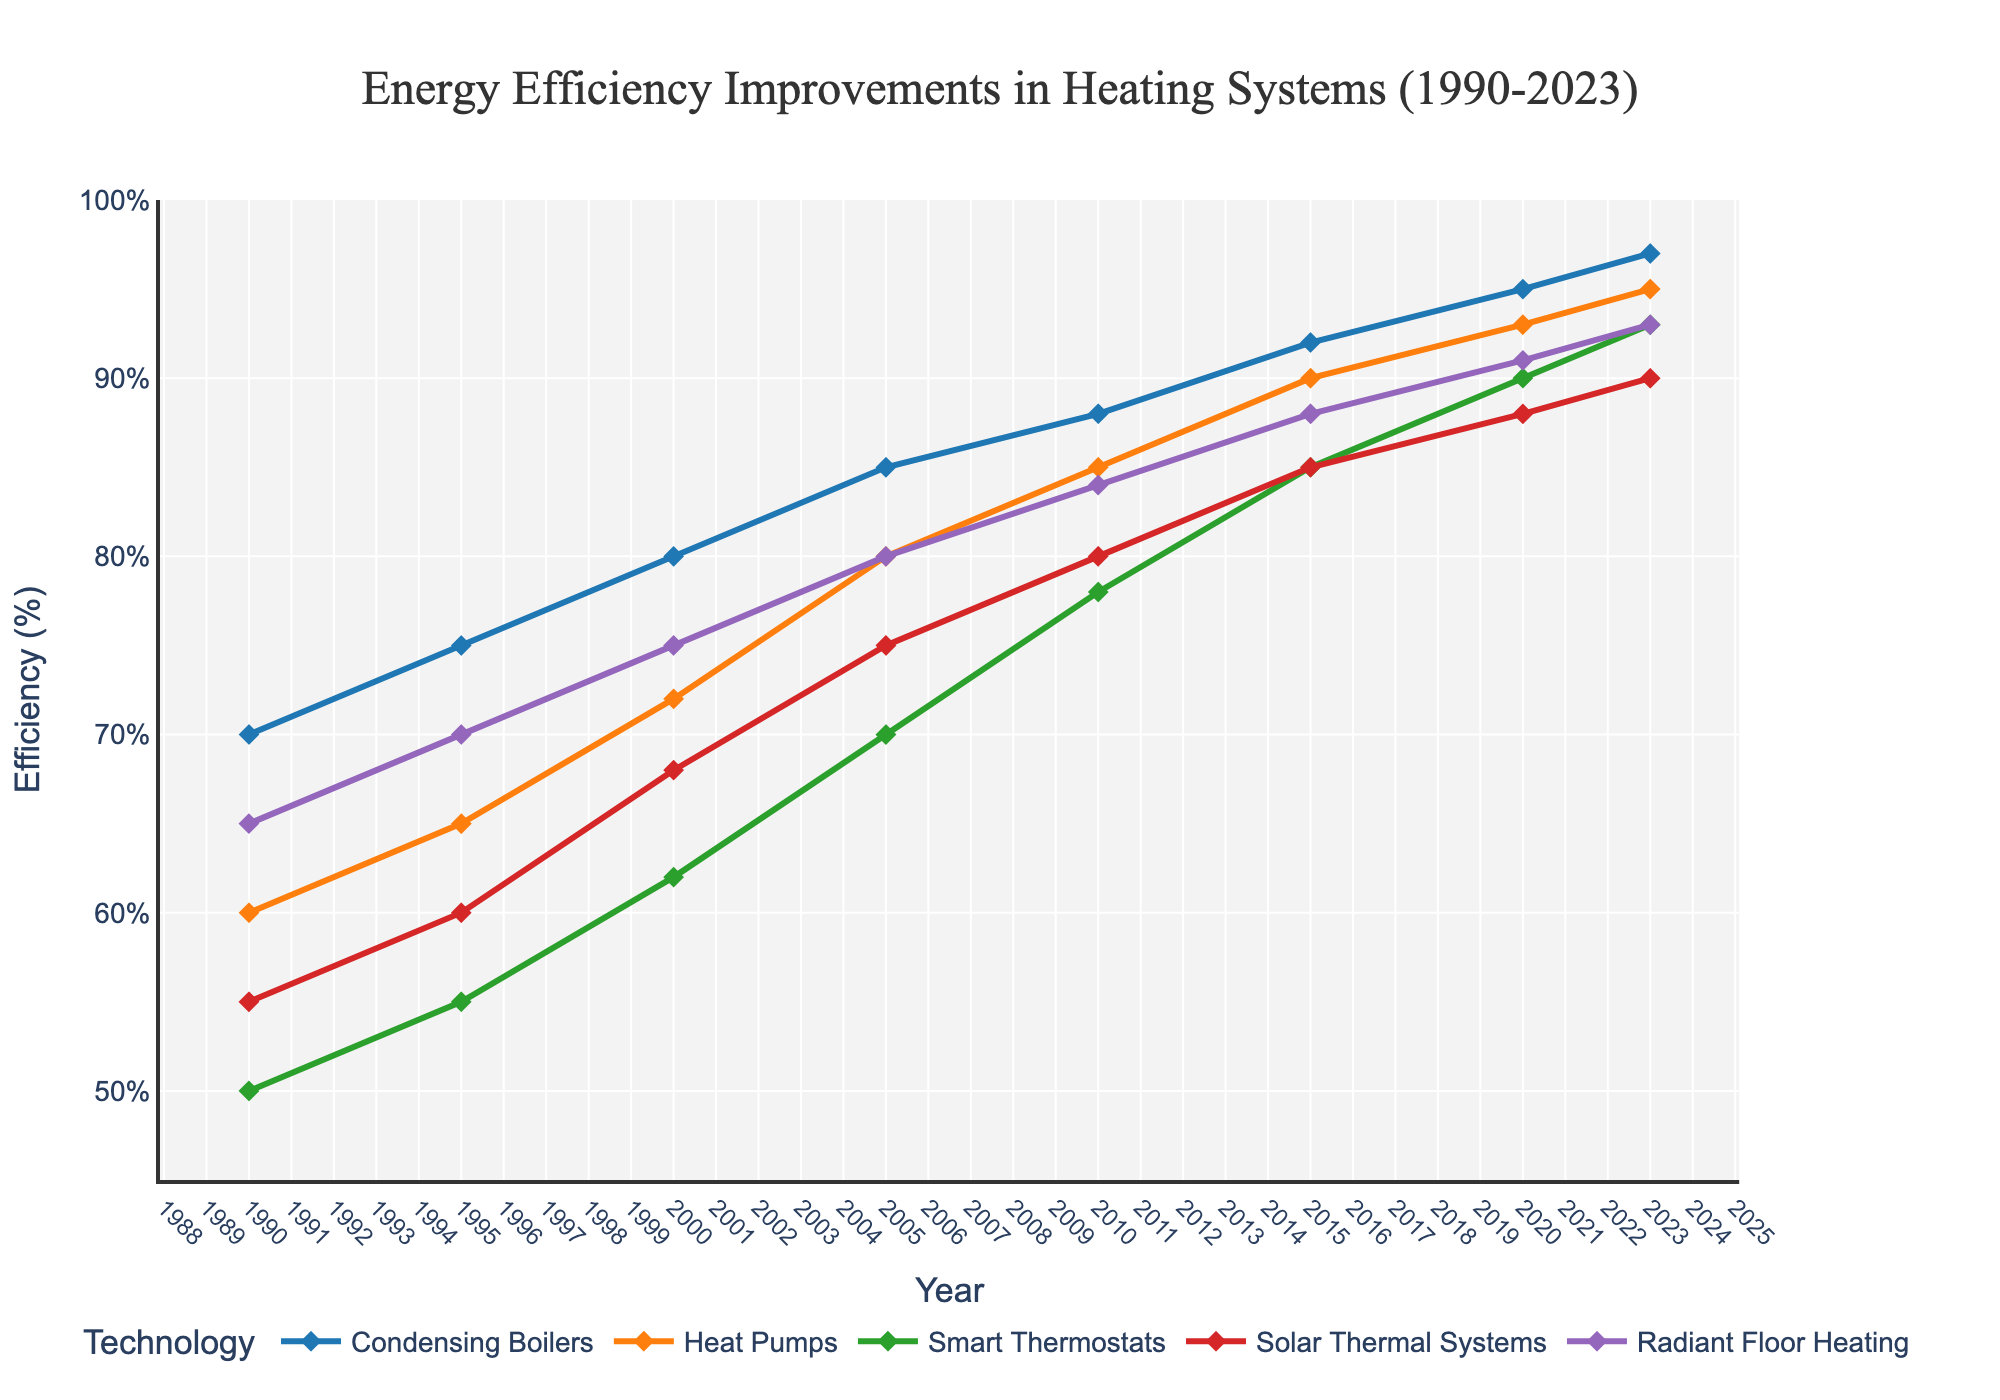What's the overall trend in energy efficiency for Condensing Boilers from 1990 to 2023? To understand the trend, we look at the data points for Condensing Boilers from 1990 to 2023. The efficiency improved from 70% in 1990 to 97% in 2023, indicating a consistent upward trend.
Answer: Increasing How much did the efficiency of Heat Pumps increase between 1990 and 2023? To find the increase, subtract the 1990 value from the 2023 value for Heat Pumps: 95% (2023) - 60% (1990) = 35%.
Answer: 35% Which technology had the highest efficiency in 2023? Look at the 2023 data points and identify the highest value: Condensing Boilers = 97, Heat Pumps = 95, Smart Thermostats = 93, Solar Thermal Systems = 90, Radiant Floor Heating = 93. Condensing Boilers have the highest efficiency at 97%.
Answer: Condensing Boilers Compare the efficiency of Solar Thermal Systems in 2010 with Radiant Floor Heating in 2000. Which one is more efficient? Look at the data points for both: Solar Thermal Systems in 2010 = 80%, Radiant Floor Heating in 2000 = 75%. Solar Thermal Systems in 2010 are more efficient.
Answer: Solar Thermal Systems in 2010 What is the average efficiency increase per decade for Smart Thermostats from 1990 to 2020? First, calculate the total increase: 90% (2020) - 50% (1990) = 40%. There are 3 decades between 1990 and 2020. Divide the total increase by 3: 40% / 3 ≈ 13.33%.
Answer: 13.33% What is the efficiency difference between Condensing Boilers and Heat Pumps in 2023? Subtract the efficiency of Heat Pumps from Condensing Boilers in 2023: 97 - 95 = 2%.
Answer: 2% How do the efficiency trends of Heat Pumps and Radiant Floor Heating compare from 1990 to 2023? Observing the trends, both technologies show a steady increase, but Heat Pumps start at 60% and end at 95%, a 35% increase. Radiant Floor Heating starts at 65% and ends at 93%, a 28% increase. Both trends are upward, but Heat Pumps have a slightly higher total increase.
Answer: Both increase; Heat Pumps have a larger increase 